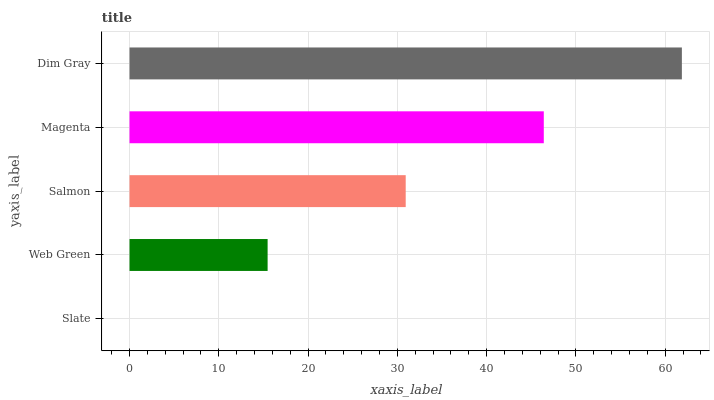Is Slate the minimum?
Answer yes or no. Yes. Is Dim Gray the maximum?
Answer yes or no. Yes. Is Web Green the minimum?
Answer yes or no. No. Is Web Green the maximum?
Answer yes or no. No. Is Web Green greater than Slate?
Answer yes or no. Yes. Is Slate less than Web Green?
Answer yes or no. Yes. Is Slate greater than Web Green?
Answer yes or no. No. Is Web Green less than Slate?
Answer yes or no. No. Is Salmon the high median?
Answer yes or no. Yes. Is Salmon the low median?
Answer yes or no. Yes. Is Web Green the high median?
Answer yes or no. No. Is Web Green the low median?
Answer yes or no. No. 